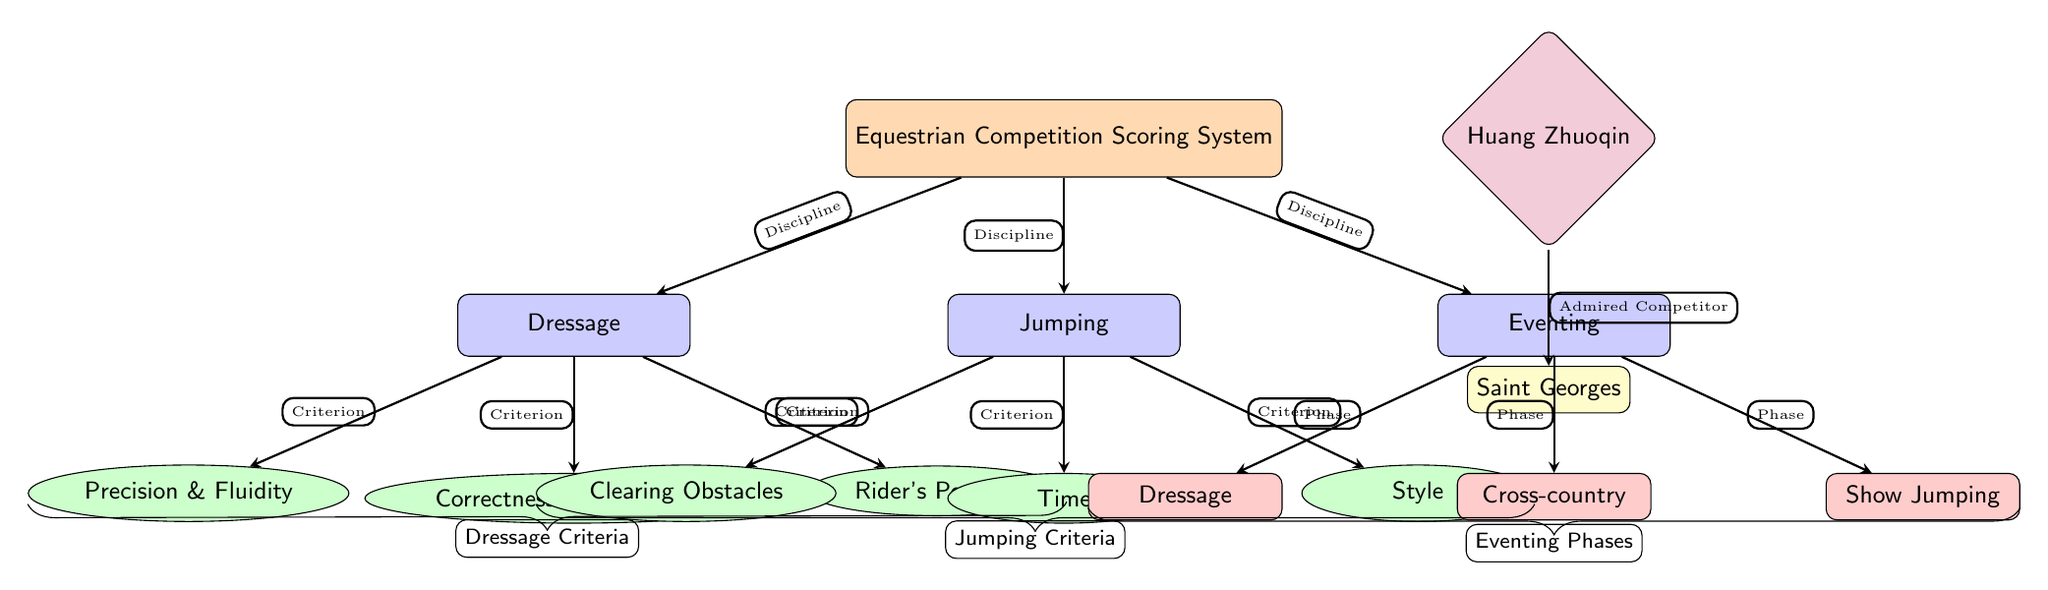What are the three main disciplines in the scoring system? The diagram indicates three main disciplines branching from the main node: Dressage, Jumping, and Eventing.
Answer: Dressage, Jumping, Eventing Which criterion is associated with the jumping discipline? The jumping discipline includes three criteria: Clearing Obstacles, Time, and Style, which are directly connected to the Jumping node.
Answer: Clearing Obstacles, Time, Style How many criteria are listed for dressage? The dressage discipline has three specific criteria: Precision & Fluidity, Correctness of Movements, and Rider's Position, all directly linked to the Dressage node.
Answer: Three What phase follows the dressage phase in eventing? The eventing discipline consists of three phases: Dressage, Cross-country, and Show Jumping. The phase that follows Dressage is Cross-country, which is clearly indicated in the diagram.
Answer: Cross-country What is the admired competitor's level? The competitor's level is shown below the competitor node and states "Saint Georges," directly indicating their proficiency level.
Answer: Saint Georges What is the relationship between Huang Zhuoqin and the scoring system? Huang Zhuoqin is directly connected to the scoring system diagram as the admired competitor, illustrating a relationship between the competitor and the overall scoring system.
Answer: Admired Competitor Identify the color used for the discipline nodes. Each discipline node, including Dressage, Jumping, and Eventing, is filled with a specific color in the diagram, which is blue (as indicated by the node style).
Answer: Blue How many phases are there in eventing? The eventing node connects to three phases, clearly listed as Dressage, Cross-country, and Show Jumping, indicating that there are three phases in total.
Answer: Three 